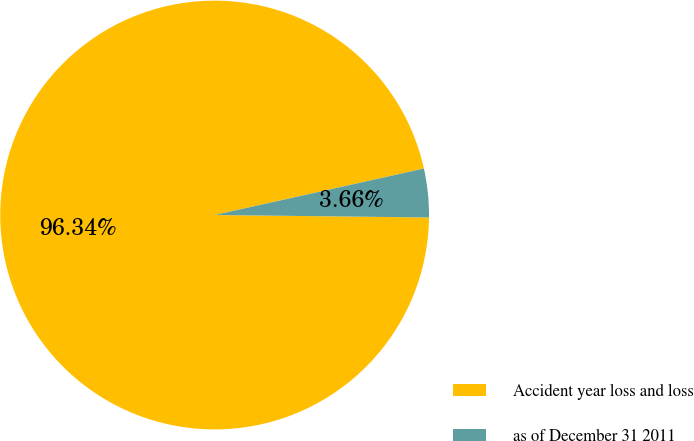Convert chart. <chart><loc_0><loc_0><loc_500><loc_500><pie_chart><fcel>Accident year loss and loss<fcel>as of December 31 2011<nl><fcel>96.34%<fcel>3.66%<nl></chart> 